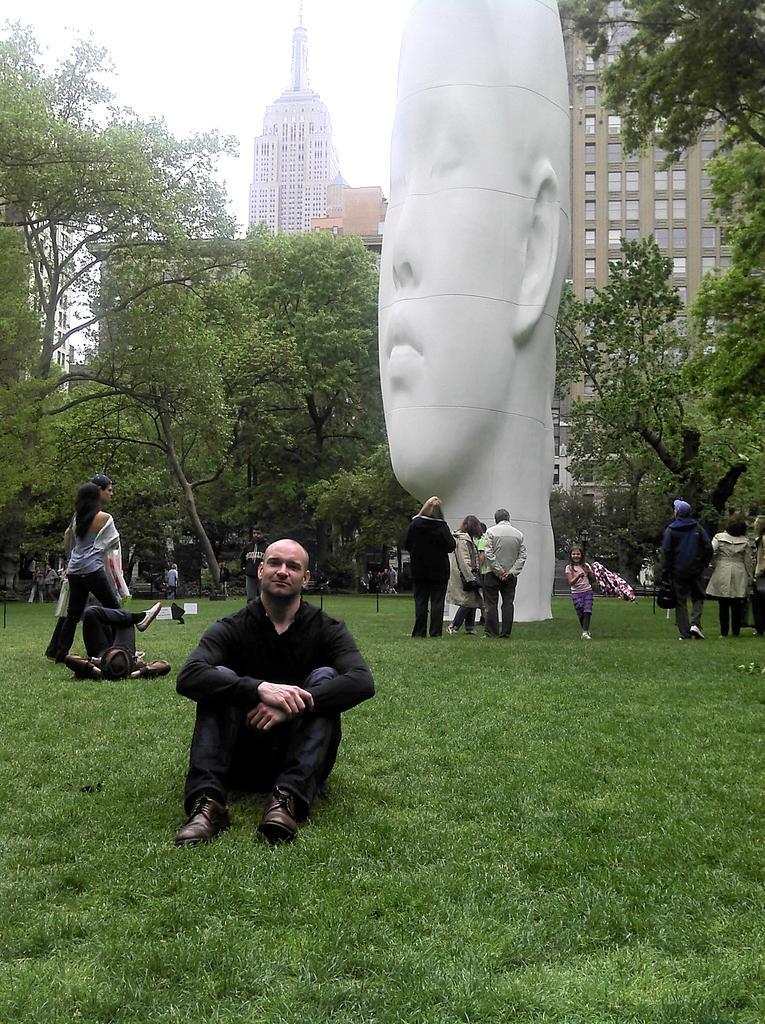Please provide a concise description of this image. In this picture I can see there is a man sitting on the grass and in the backdrop, there are a few more people standing, there is a statue of a face of a man. There are trees in the backdrop, there are buildings with glass windows and the sky is clear. 